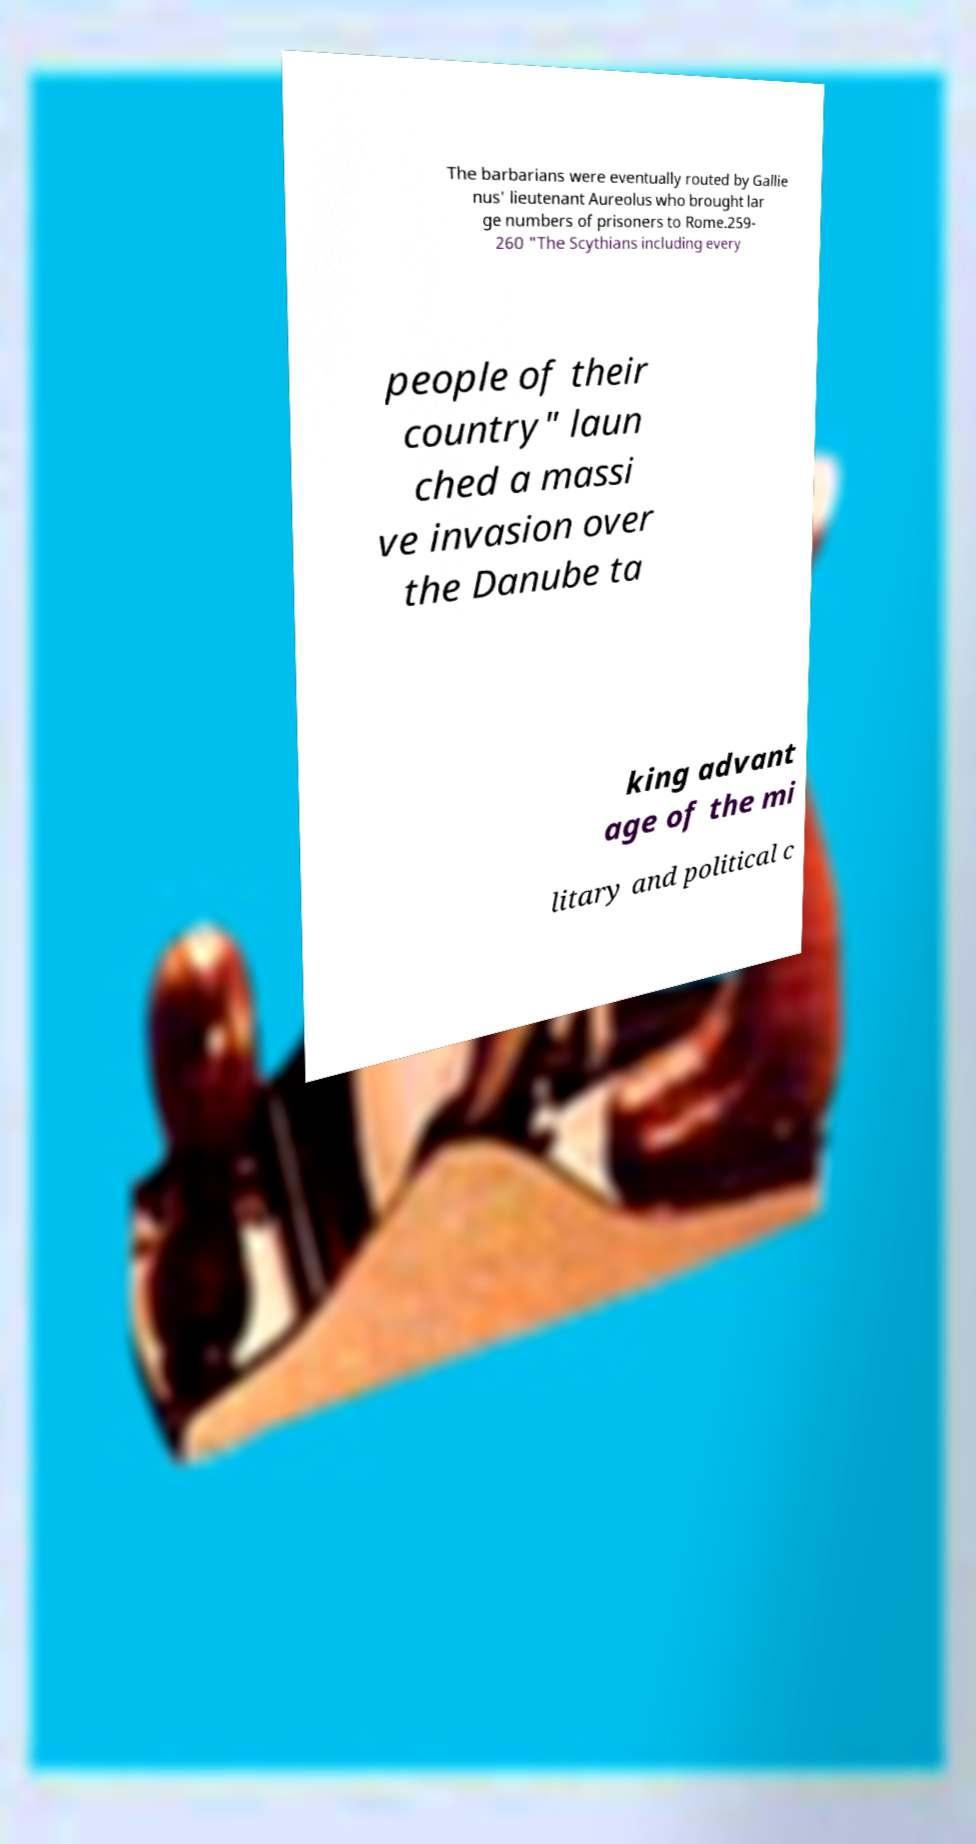Could you extract and type out the text from this image? The barbarians were eventually routed by Gallie nus' lieutenant Aureolus who brought lar ge numbers of prisoners to Rome.259- 260 "The Scythians including every people of their country" laun ched a massi ve invasion over the Danube ta king advant age of the mi litary and political c 